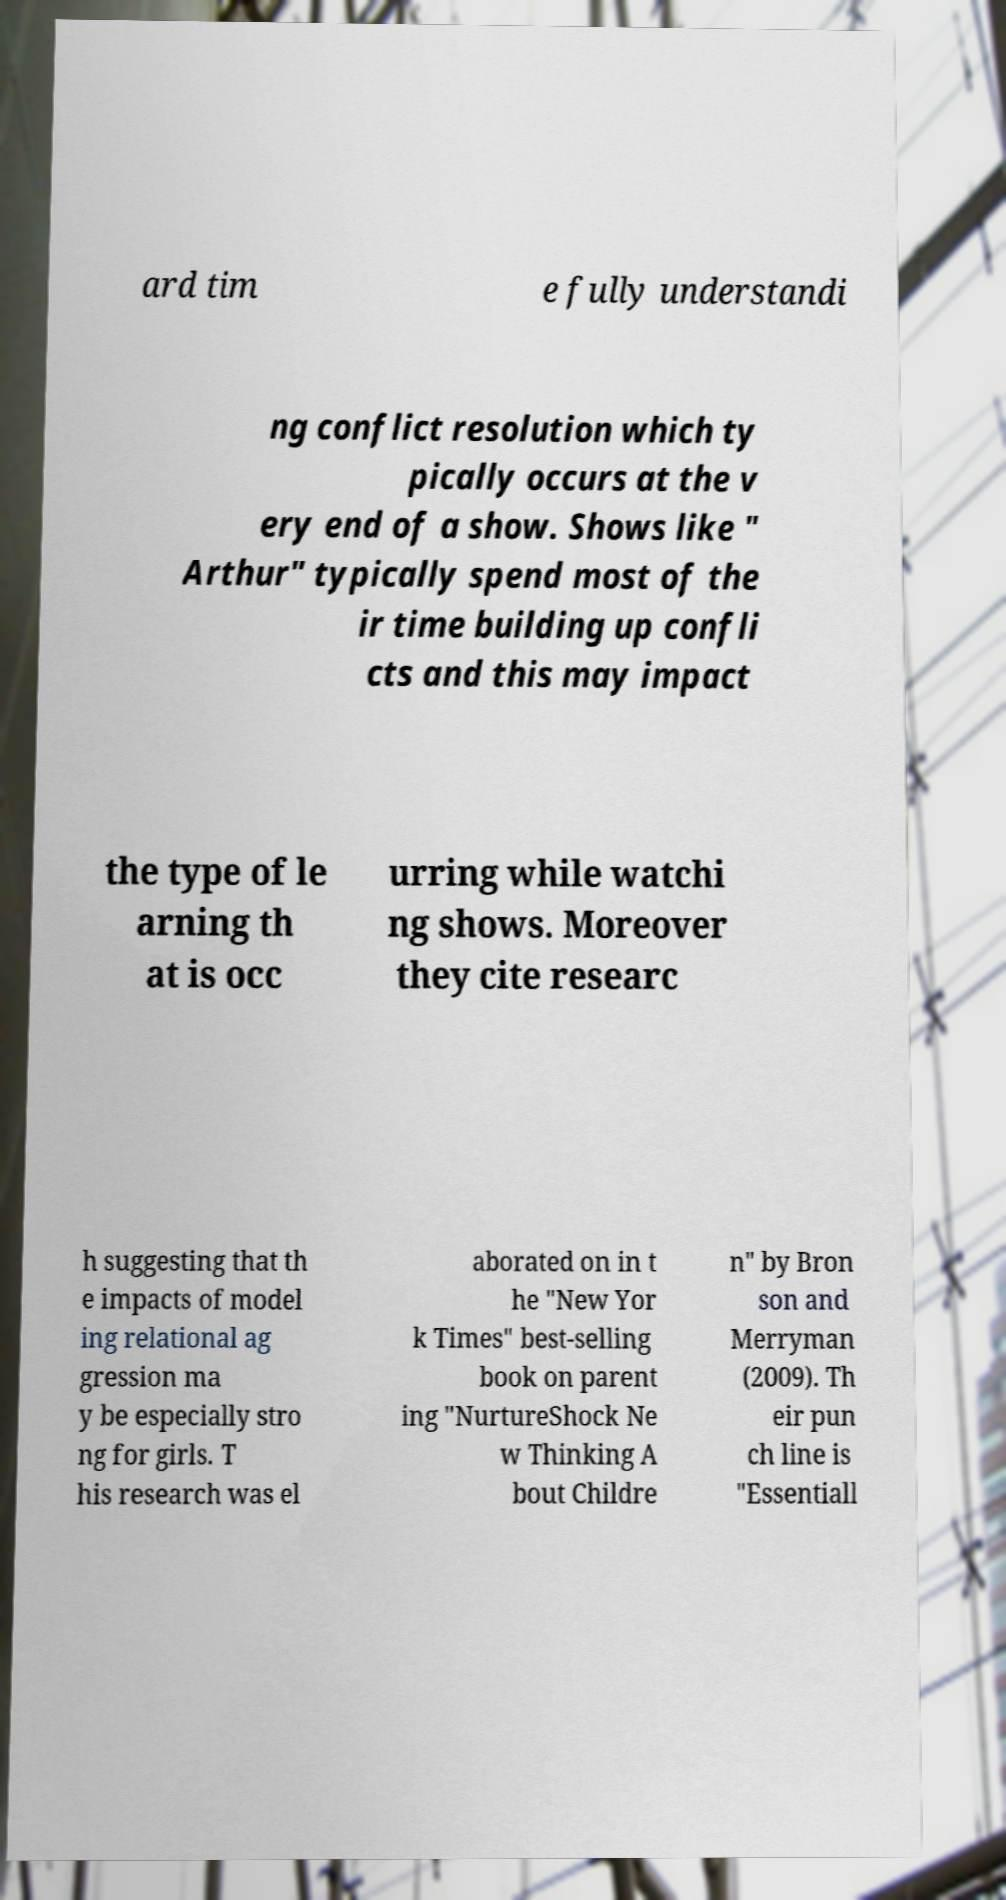Please identify and transcribe the text found in this image. ard tim e fully understandi ng conflict resolution which ty pically occurs at the v ery end of a show. Shows like " Arthur" typically spend most of the ir time building up confli cts and this may impact the type of le arning th at is occ urring while watchi ng shows. Moreover they cite researc h suggesting that th e impacts of model ing relational ag gression ma y be especially stro ng for girls. T his research was el aborated on in t he "New Yor k Times" best-selling book on parent ing "NurtureShock Ne w Thinking A bout Childre n" by Bron son and Merryman (2009). Th eir pun ch line is "Essentiall 